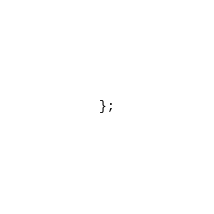<code> <loc_0><loc_0><loc_500><loc_500><_TypeScript_>};
</code> 